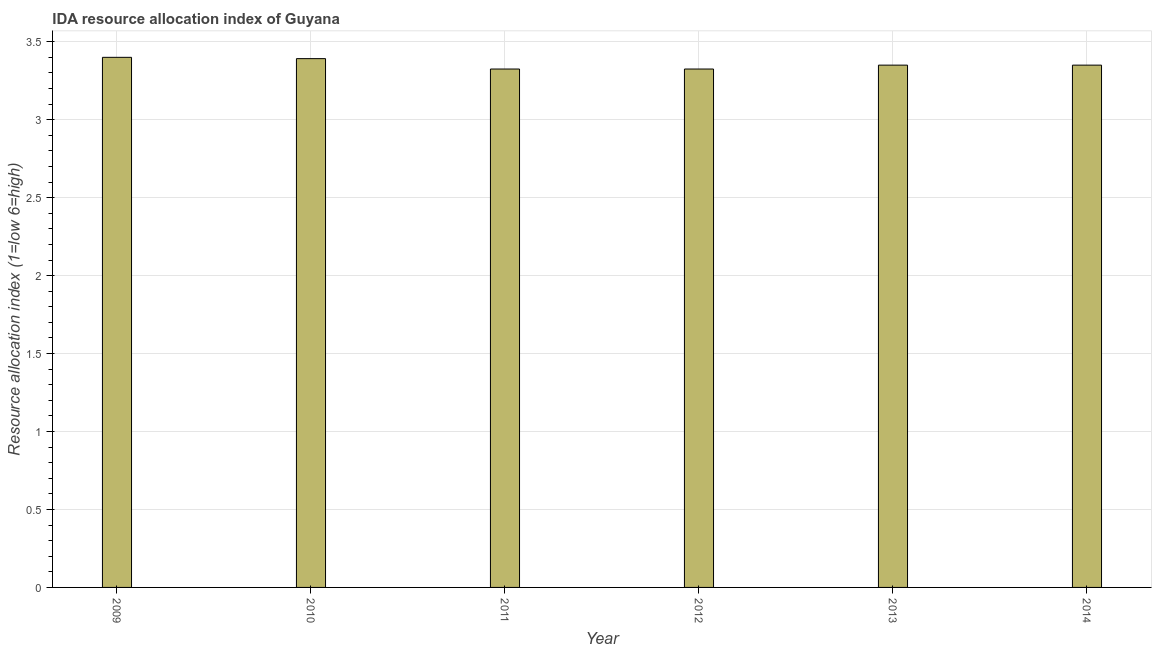Does the graph contain grids?
Offer a very short reply. Yes. What is the title of the graph?
Ensure brevity in your answer.  IDA resource allocation index of Guyana. What is the label or title of the Y-axis?
Your answer should be compact. Resource allocation index (1=low 6=high). What is the ida resource allocation index in 2014?
Your answer should be compact. 3.35. Across all years, what is the maximum ida resource allocation index?
Provide a succinct answer. 3.4. Across all years, what is the minimum ida resource allocation index?
Provide a short and direct response. 3.33. In which year was the ida resource allocation index minimum?
Ensure brevity in your answer.  2011. What is the sum of the ida resource allocation index?
Your answer should be compact. 20.14. What is the difference between the ida resource allocation index in 2010 and 2012?
Provide a short and direct response. 0.07. What is the average ida resource allocation index per year?
Your answer should be compact. 3.36. What is the median ida resource allocation index?
Your answer should be very brief. 3.35. Is the difference between the ida resource allocation index in 2011 and 2012 greater than the difference between any two years?
Your response must be concise. No. What is the difference between the highest and the second highest ida resource allocation index?
Your response must be concise. 0.01. Is the sum of the ida resource allocation index in 2011 and 2013 greater than the maximum ida resource allocation index across all years?
Offer a terse response. Yes. What is the difference between the highest and the lowest ida resource allocation index?
Make the answer very short. 0.07. What is the difference between two consecutive major ticks on the Y-axis?
Provide a succinct answer. 0.5. Are the values on the major ticks of Y-axis written in scientific E-notation?
Offer a very short reply. No. What is the Resource allocation index (1=low 6=high) in 2010?
Make the answer very short. 3.39. What is the Resource allocation index (1=low 6=high) in 2011?
Make the answer very short. 3.33. What is the Resource allocation index (1=low 6=high) in 2012?
Ensure brevity in your answer.  3.33. What is the Resource allocation index (1=low 6=high) in 2013?
Your answer should be compact. 3.35. What is the Resource allocation index (1=low 6=high) in 2014?
Offer a terse response. 3.35. What is the difference between the Resource allocation index (1=low 6=high) in 2009 and 2010?
Your response must be concise. 0.01. What is the difference between the Resource allocation index (1=low 6=high) in 2009 and 2011?
Your response must be concise. 0.07. What is the difference between the Resource allocation index (1=low 6=high) in 2009 and 2012?
Your answer should be compact. 0.07. What is the difference between the Resource allocation index (1=low 6=high) in 2010 and 2011?
Ensure brevity in your answer.  0.07. What is the difference between the Resource allocation index (1=low 6=high) in 2010 and 2012?
Keep it short and to the point. 0.07. What is the difference between the Resource allocation index (1=low 6=high) in 2010 and 2013?
Give a very brief answer. 0.04. What is the difference between the Resource allocation index (1=low 6=high) in 2010 and 2014?
Your response must be concise. 0.04. What is the difference between the Resource allocation index (1=low 6=high) in 2011 and 2012?
Your response must be concise. 0. What is the difference between the Resource allocation index (1=low 6=high) in 2011 and 2013?
Provide a short and direct response. -0.03. What is the difference between the Resource allocation index (1=low 6=high) in 2011 and 2014?
Provide a succinct answer. -0.03. What is the difference between the Resource allocation index (1=low 6=high) in 2012 and 2013?
Give a very brief answer. -0.03. What is the difference between the Resource allocation index (1=low 6=high) in 2012 and 2014?
Provide a succinct answer. -0.03. What is the ratio of the Resource allocation index (1=low 6=high) in 2009 to that in 2012?
Your response must be concise. 1.02. What is the ratio of the Resource allocation index (1=low 6=high) in 2009 to that in 2014?
Make the answer very short. 1.01. What is the ratio of the Resource allocation index (1=low 6=high) in 2010 to that in 2013?
Your answer should be compact. 1.01. What is the ratio of the Resource allocation index (1=low 6=high) in 2011 to that in 2012?
Provide a short and direct response. 1. What is the ratio of the Resource allocation index (1=low 6=high) in 2012 to that in 2013?
Provide a short and direct response. 0.99. What is the ratio of the Resource allocation index (1=low 6=high) in 2012 to that in 2014?
Your answer should be compact. 0.99. What is the ratio of the Resource allocation index (1=low 6=high) in 2013 to that in 2014?
Ensure brevity in your answer.  1. 